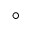Convert formula to latex. <formula><loc_0><loc_0><loc_500><loc_500>^ { \circ }</formula> 